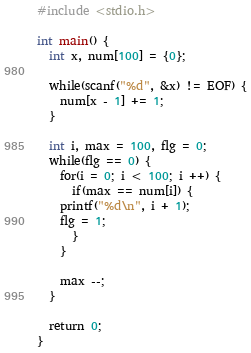Convert code to text. <code><loc_0><loc_0><loc_500><loc_500><_C_>#include <stdio.h>

int main() {
  int x, num[100] = {0};

  while(scanf("%d", &x) != EOF) {
    num[x - 1] += 1;
  }

  int i, max = 100, flg = 0;
  while(flg == 0) {
    for(i = 0; i < 100; i ++) {
      if(max == num[i]) {
	printf("%d\n", i + 1);
	flg = 1;
      }
    }

    max --;
  }

  return 0;
}</code> 